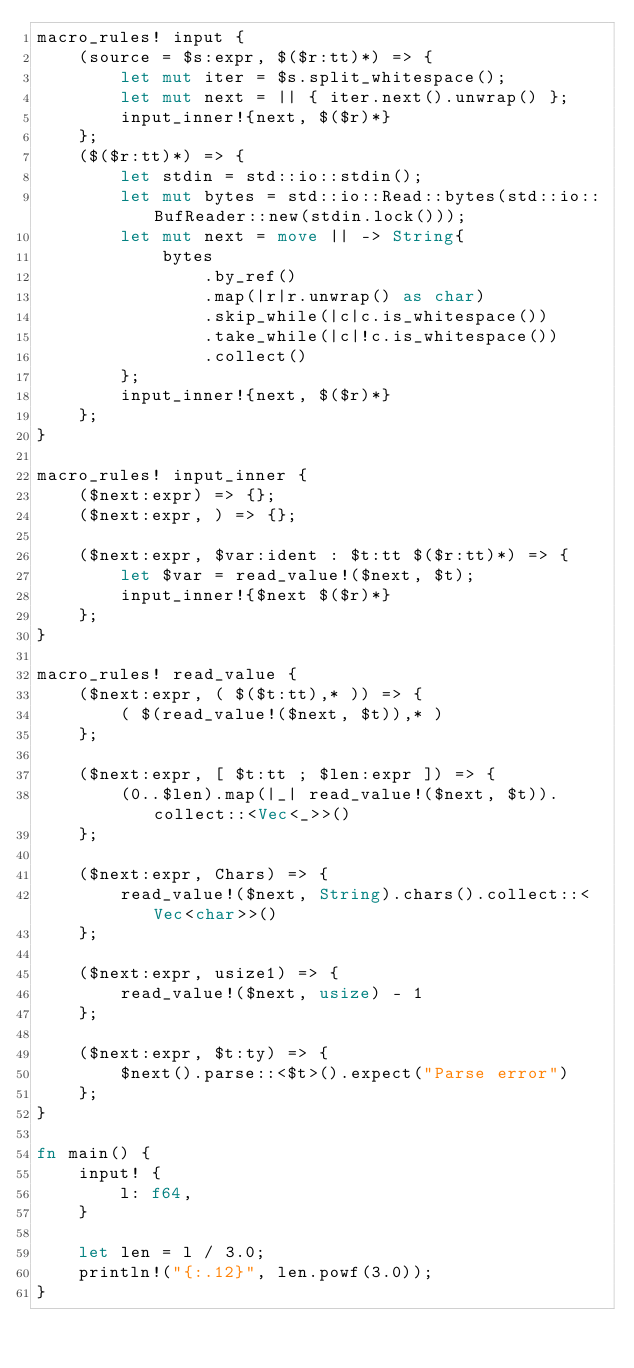Convert code to text. <code><loc_0><loc_0><loc_500><loc_500><_Rust_>macro_rules! input {
    (source = $s:expr, $($r:tt)*) => {
        let mut iter = $s.split_whitespace();
        let mut next = || { iter.next().unwrap() };
        input_inner!{next, $($r)*}
    };
    ($($r:tt)*) => {
        let stdin = std::io::stdin();
        let mut bytes = std::io::Read::bytes(std::io::BufReader::new(stdin.lock()));
        let mut next = move || -> String{
            bytes
                .by_ref()
                .map(|r|r.unwrap() as char)
                .skip_while(|c|c.is_whitespace())
                .take_while(|c|!c.is_whitespace())
                .collect()
        };
        input_inner!{next, $($r)*}
    };
}
 
macro_rules! input_inner {
    ($next:expr) => {};
    ($next:expr, ) => {};
 
    ($next:expr, $var:ident : $t:tt $($r:tt)*) => {
        let $var = read_value!($next, $t);
        input_inner!{$next $($r)*}
    };
}
 
macro_rules! read_value {
    ($next:expr, ( $($t:tt),* )) => {
        ( $(read_value!($next, $t)),* )
    };
 
    ($next:expr, [ $t:tt ; $len:expr ]) => {
        (0..$len).map(|_| read_value!($next, $t)).collect::<Vec<_>>()
    };
 
    ($next:expr, Chars) => {
        read_value!($next, String).chars().collect::<Vec<char>>()
    };
 
    ($next:expr, usize1) => {
        read_value!($next, usize) - 1
    };
 
    ($next:expr, $t:ty) => {
        $next().parse::<$t>().expect("Parse error")
    };
}

fn main() {
    input! {
        l: f64,
    }

    let len = l / 3.0;
    println!("{:.12}", len.powf(3.0));
}
</code> 